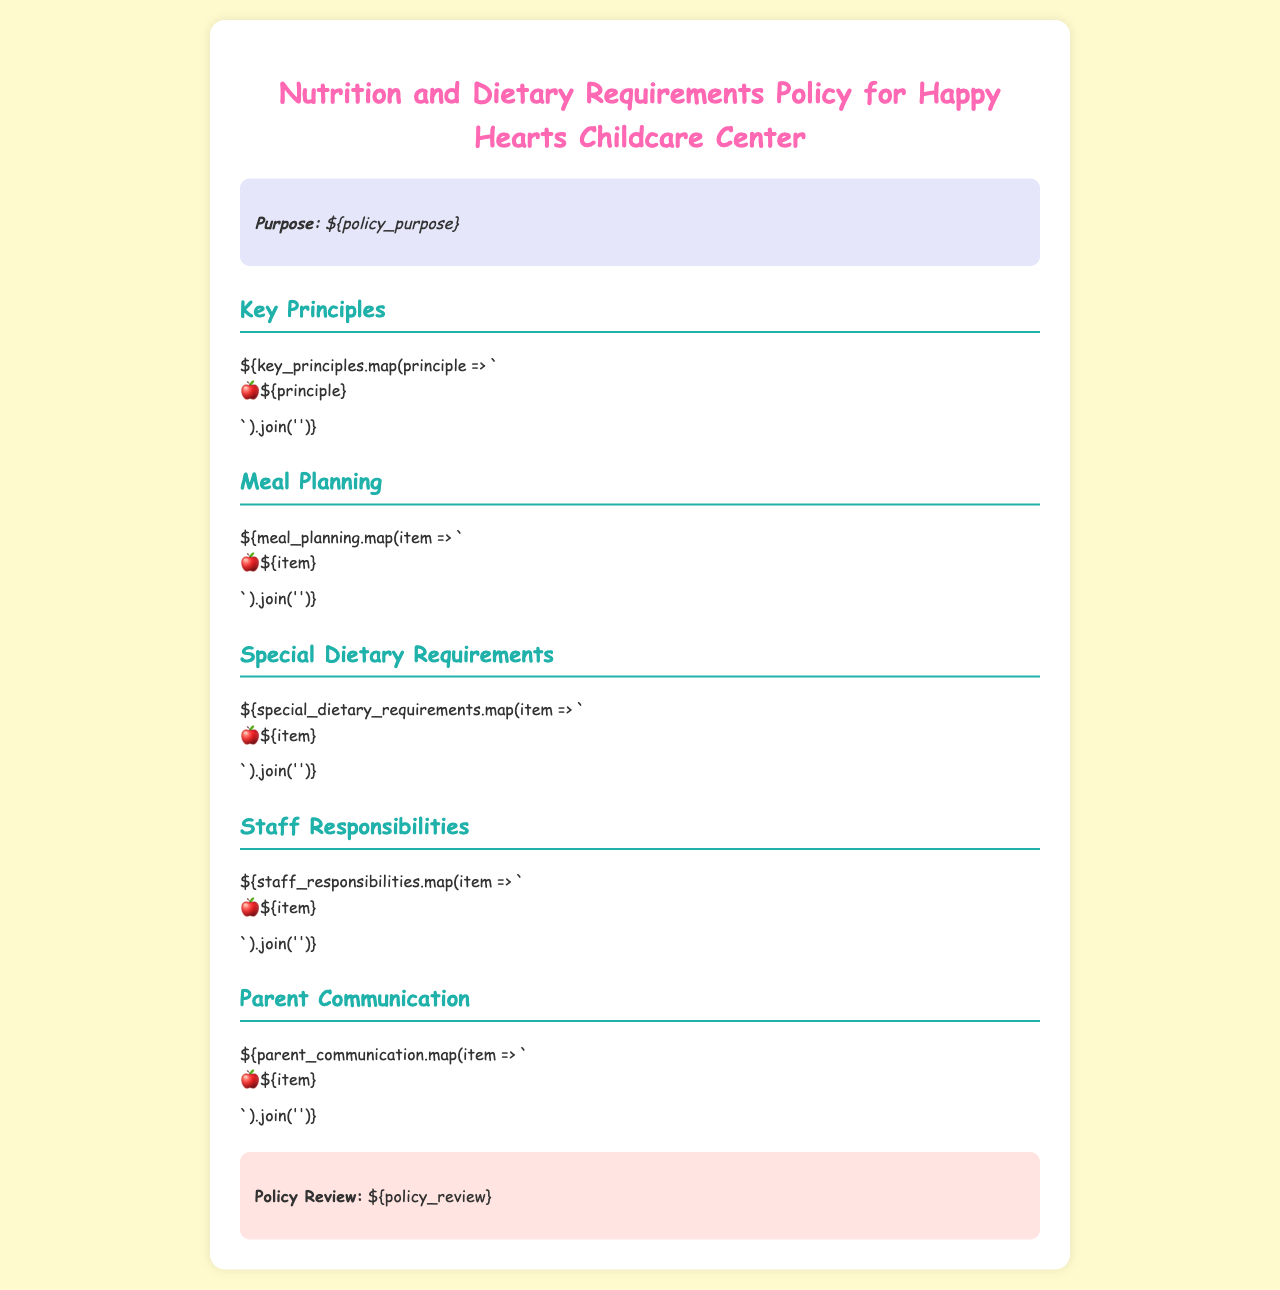What is the purpose of the policy? The purpose is stated in the section under "Purpose" in the document.
Answer: ${policy_purpose} How many key principles are outlined in the policy? This information can be found in the "Key Principles" section which lists the principles.
Answer: ${key_principles.length} What meal planning considerations are included? Meal planning considerations are listed in the "Meal Planning" section of the document.
Answer: ${meal_planning.join(', ')} What should be done to accommodate special dietary needs? This information is provided in the "Special Dietary Requirements" section.
Answer: ${special_dietary_requirements.join(', ')} Who is responsible for implementing the policy? Staff responsibilities are enumerated in the "Staff Responsibilities" section.
Answer: ${staff_responsibilities.join(', ')} How will parents be informed about the dietary policy? Parent communication strategies are listed in the "Parent Communication" section.
Answer: ${parent_communication.join(', ')} When will the policy be reviewed? The review schedule is outlined in the "Policy Review" section of the document.
Answer: ${policy_review} What type of meals does the policy aim to provide? The type of meals is inferred from the "Meal Planning" section.
Answer: Balanced meals What role does the nurse play in this policy? The nurse's role is implied in the responsibilities and communication sections, particularly related to health.
Answer: Health monitoring 